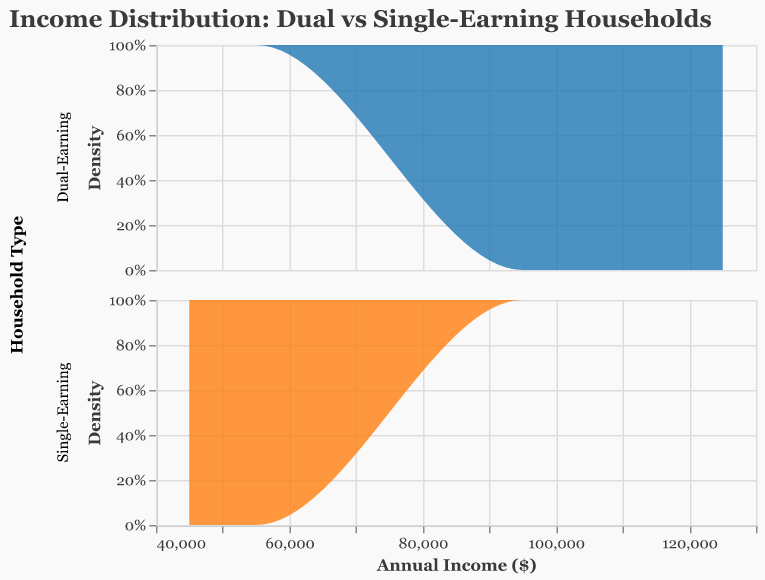What is the title of the figure? The title of the figure is displayed as text at the top of the plot. It reads "Income Distribution: Dual vs Single-Earning Households".
Answer: Income Distribution: Dual vs Single-Earning Households What are the colors used to represent Dual-Earning and Single-Earning households? The color representing Dual-Earning households is blue and the color representing Single-Earning households is orange. This can be inferred from the legend and the density plot colors.
Answer: Blue and Orange Which type of households generally have higher income based on the density plot? By comparing the density plots, it is evident that the peak income values for Dual-Earning households are much higher compared to those for Single-Earning households.
Answer: Dual-Earning households What is the range of incomes for Single-Earning households? By examining the horizontal axis of the plot for Single-Earning households, we see income values starting from around $45,000 to $55,000.
Answer: $45,000 to $55,000 What is the income range where Dual-Earning households have the highest density? From the density plot for Dual-Earning households, the highest density is observed in the range of approximately $95,000 to $125,000.
Answer: $95,000 to $125,000 How does the shape of the income distribution for Dual-Earning households compare to that of Single-Earning households? The Dual-Earning households have a wider, more spread-out distribution with a peak around $110,000, while Single-Earning households have a narrower distribution with a peak around $50,000.
Answer: Dual-Earning is wider, Single-Earning is narrower Which household type has a higher density at their respective peaks? By comparing the height of the peaks in the density plots, we observe that the peak density for Single-Earning households is higher compared to that of Dual-Earning households.
Answer: Single-Earning households What could be a possible reason for the observed income distribution pattern in Dual-Earning households? Dual-Earning households naturally have two income sources contributing to the total household income, which generally results in higher combined earnings compared to a single source in Single-Earning households.
Answer: Due to two income sources What is the total number of data points for Single-Earning and Dual-Earning households? By counting the data points listed, there are 10 Single-Earning households and 10 Dual-Earning households.
Answer: 10 Single-Earning, 10 Dual-Earning What can you infer about economic disparities between Single-Earning and Dual-Earning households from this plot? The economic disparity is indicated by the significant difference in income ranges, with Dual-Earning households having substantially higher incomes and a broader distribution than Single-Earning households.
Answer: Significant economic disparity 